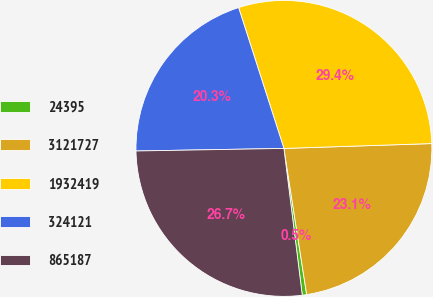<chart> <loc_0><loc_0><loc_500><loc_500><pie_chart><fcel>24395<fcel>3121727<fcel>1932419<fcel>324121<fcel>865187<nl><fcel>0.48%<fcel>23.06%<fcel>29.43%<fcel>20.32%<fcel>26.7%<nl></chart> 